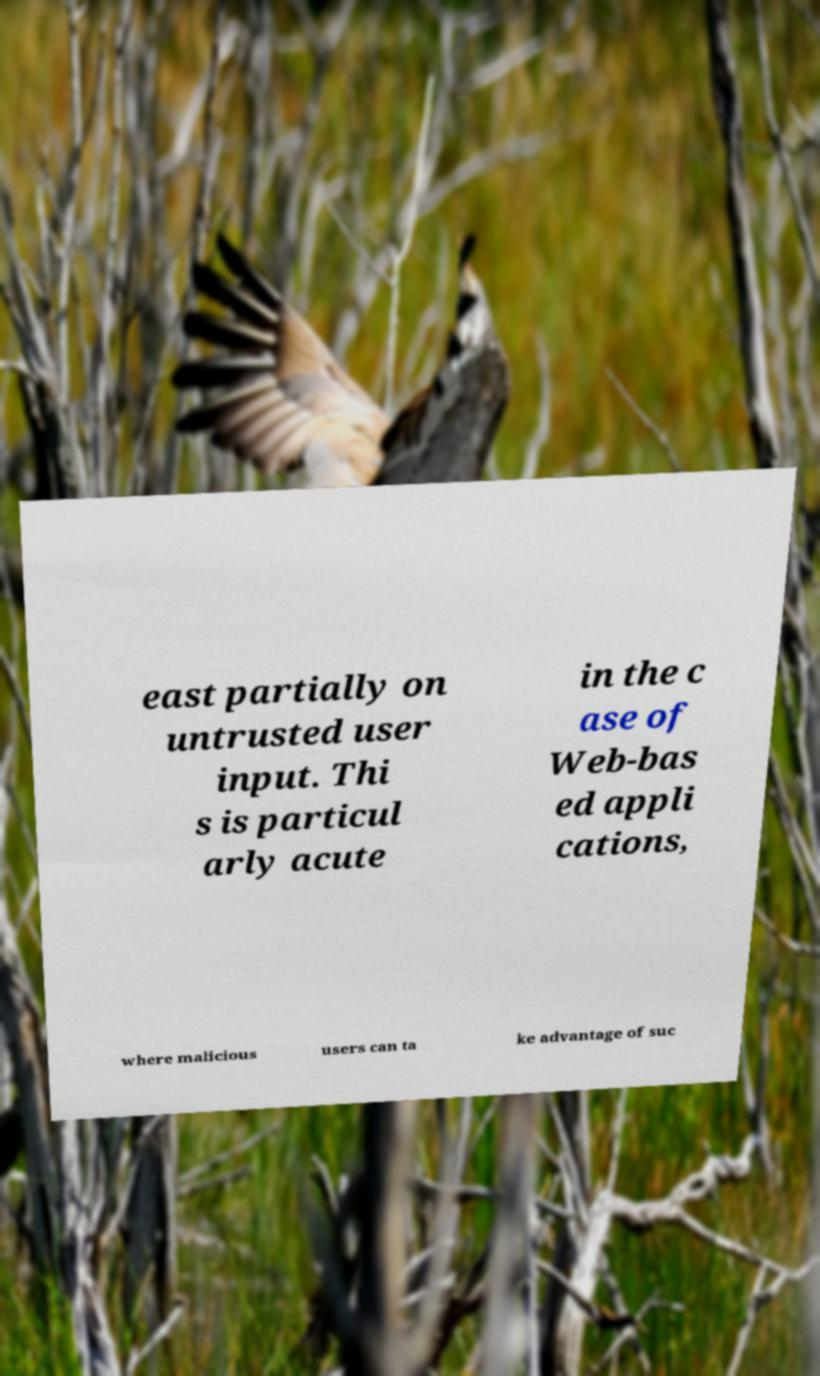Could you assist in decoding the text presented in this image and type it out clearly? east partially on untrusted user input. Thi s is particul arly acute in the c ase of Web-bas ed appli cations, where malicious users can ta ke advantage of suc 